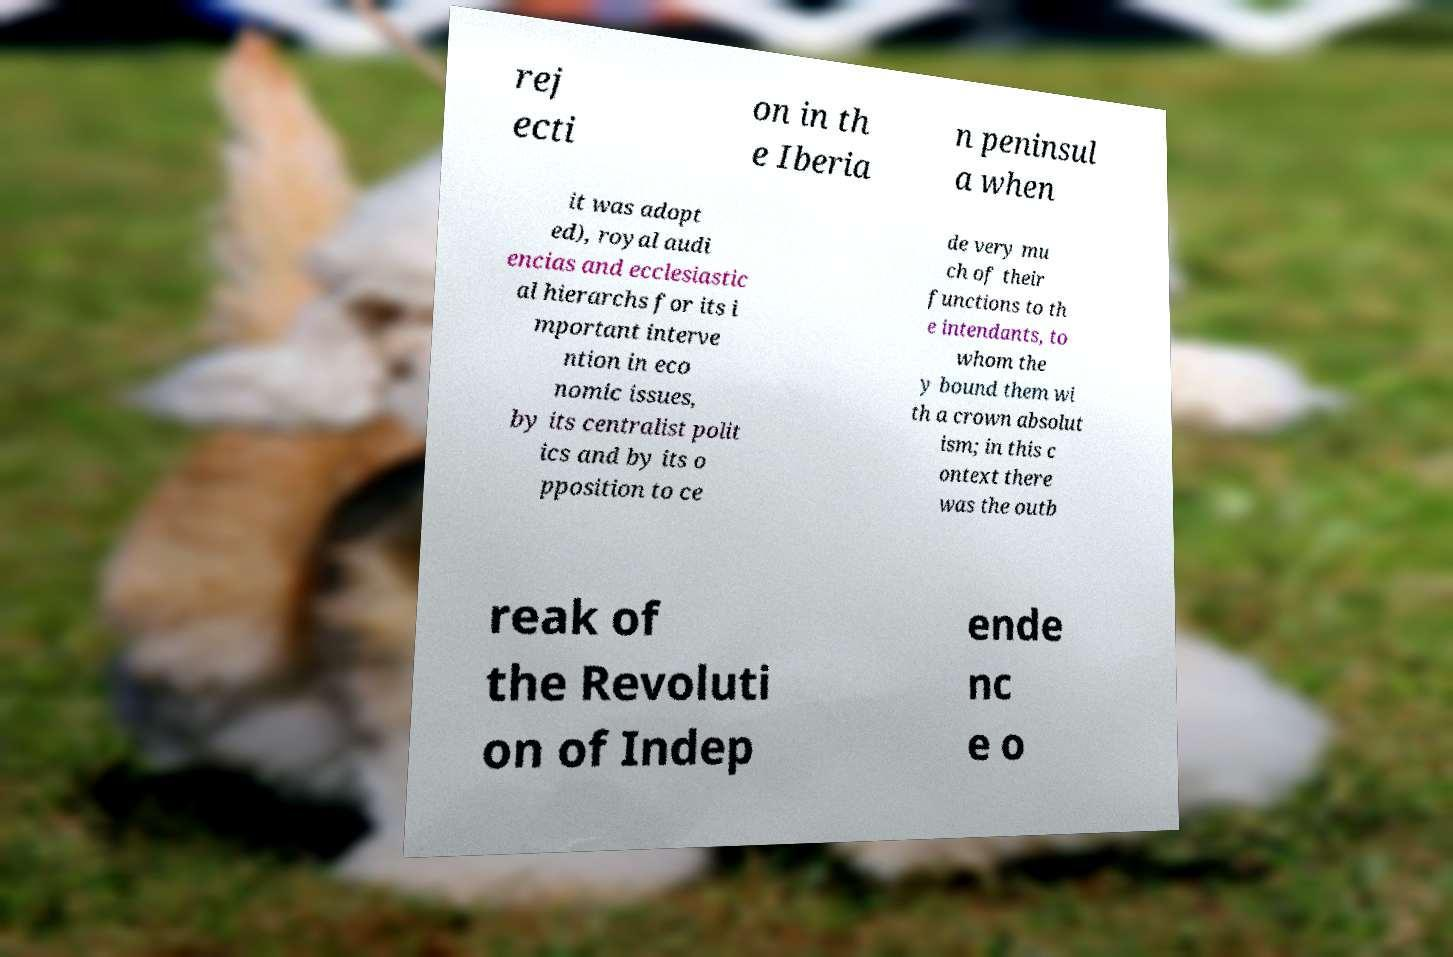For documentation purposes, I need the text within this image transcribed. Could you provide that? rej ecti on in th e Iberia n peninsul a when it was adopt ed), royal audi encias and ecclesiastic al hierarchs for its i mportant interve ntion in eco nomic issues, by its centralist polit ics and by its o pposition to ce de very mu ch of their functions to th e intendants, to whom the y bound them wi th a crown absolut ism; in this c ontext there was the outb reak of the Revoluti on of Indep ende nc e o 